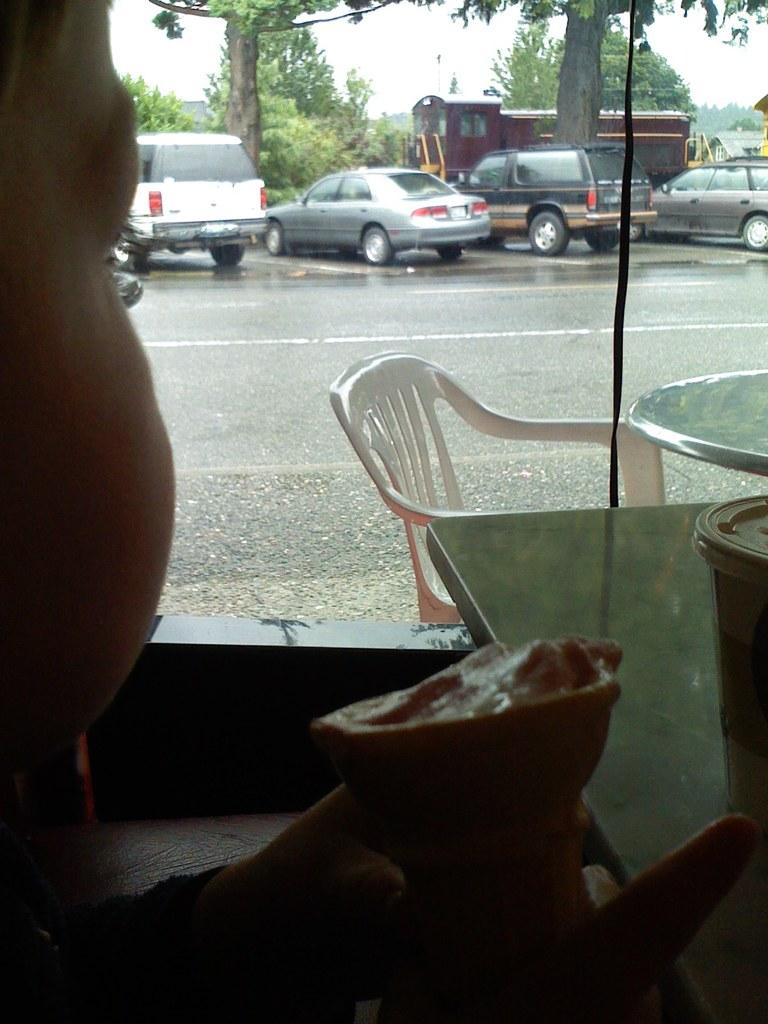What is the kid in the image holding? The kid is holding an ice-cream. What can be seen through the glass window in the image? Tables, chairs, vehicles on the road, and trees can be seen through the window. What type of rock is the girl holding in the image? There is no girl or rock present in the image. What button is the kid wearing on their shirt in the image? There is no button mentioned or visible on the kid's shirt in the image. 